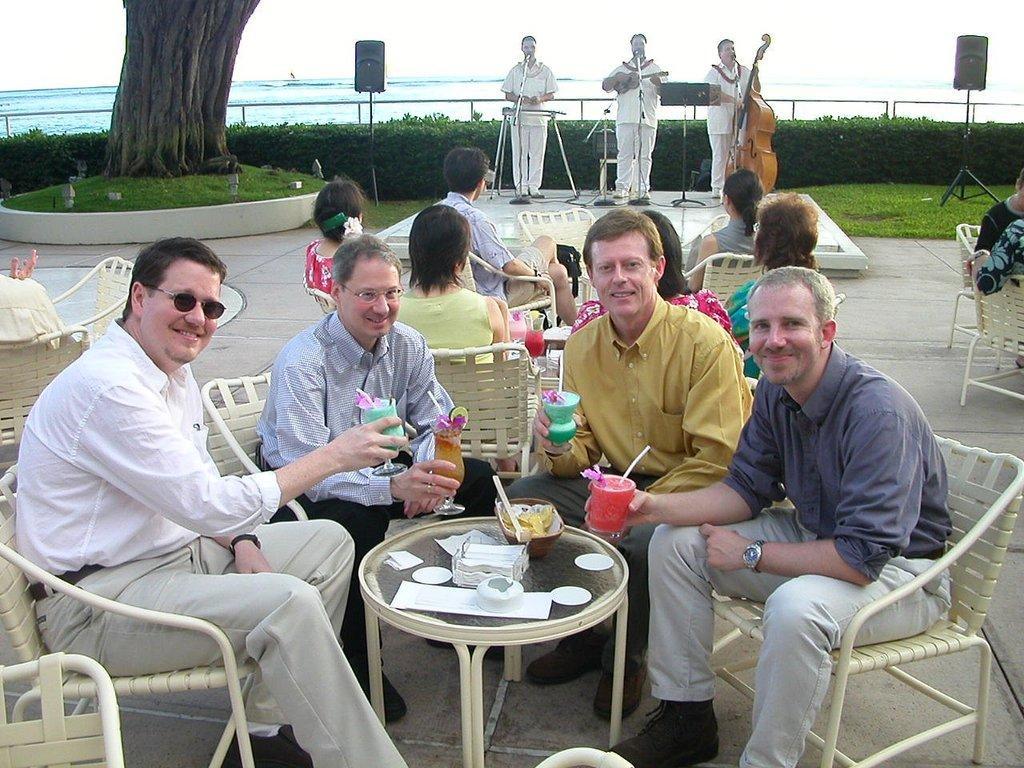In one or two sentences, can you explain what this image depicts? This is a picture taken in the outdoors. It is sunny. There are a group of people sitting on a chair holding the cups in front of the people there is a table on the table there is a bowl with spoon and tissues. Background of this people there are three persons standing on a stage and playing music instruments and singing a song and bushes and speaker and water. 